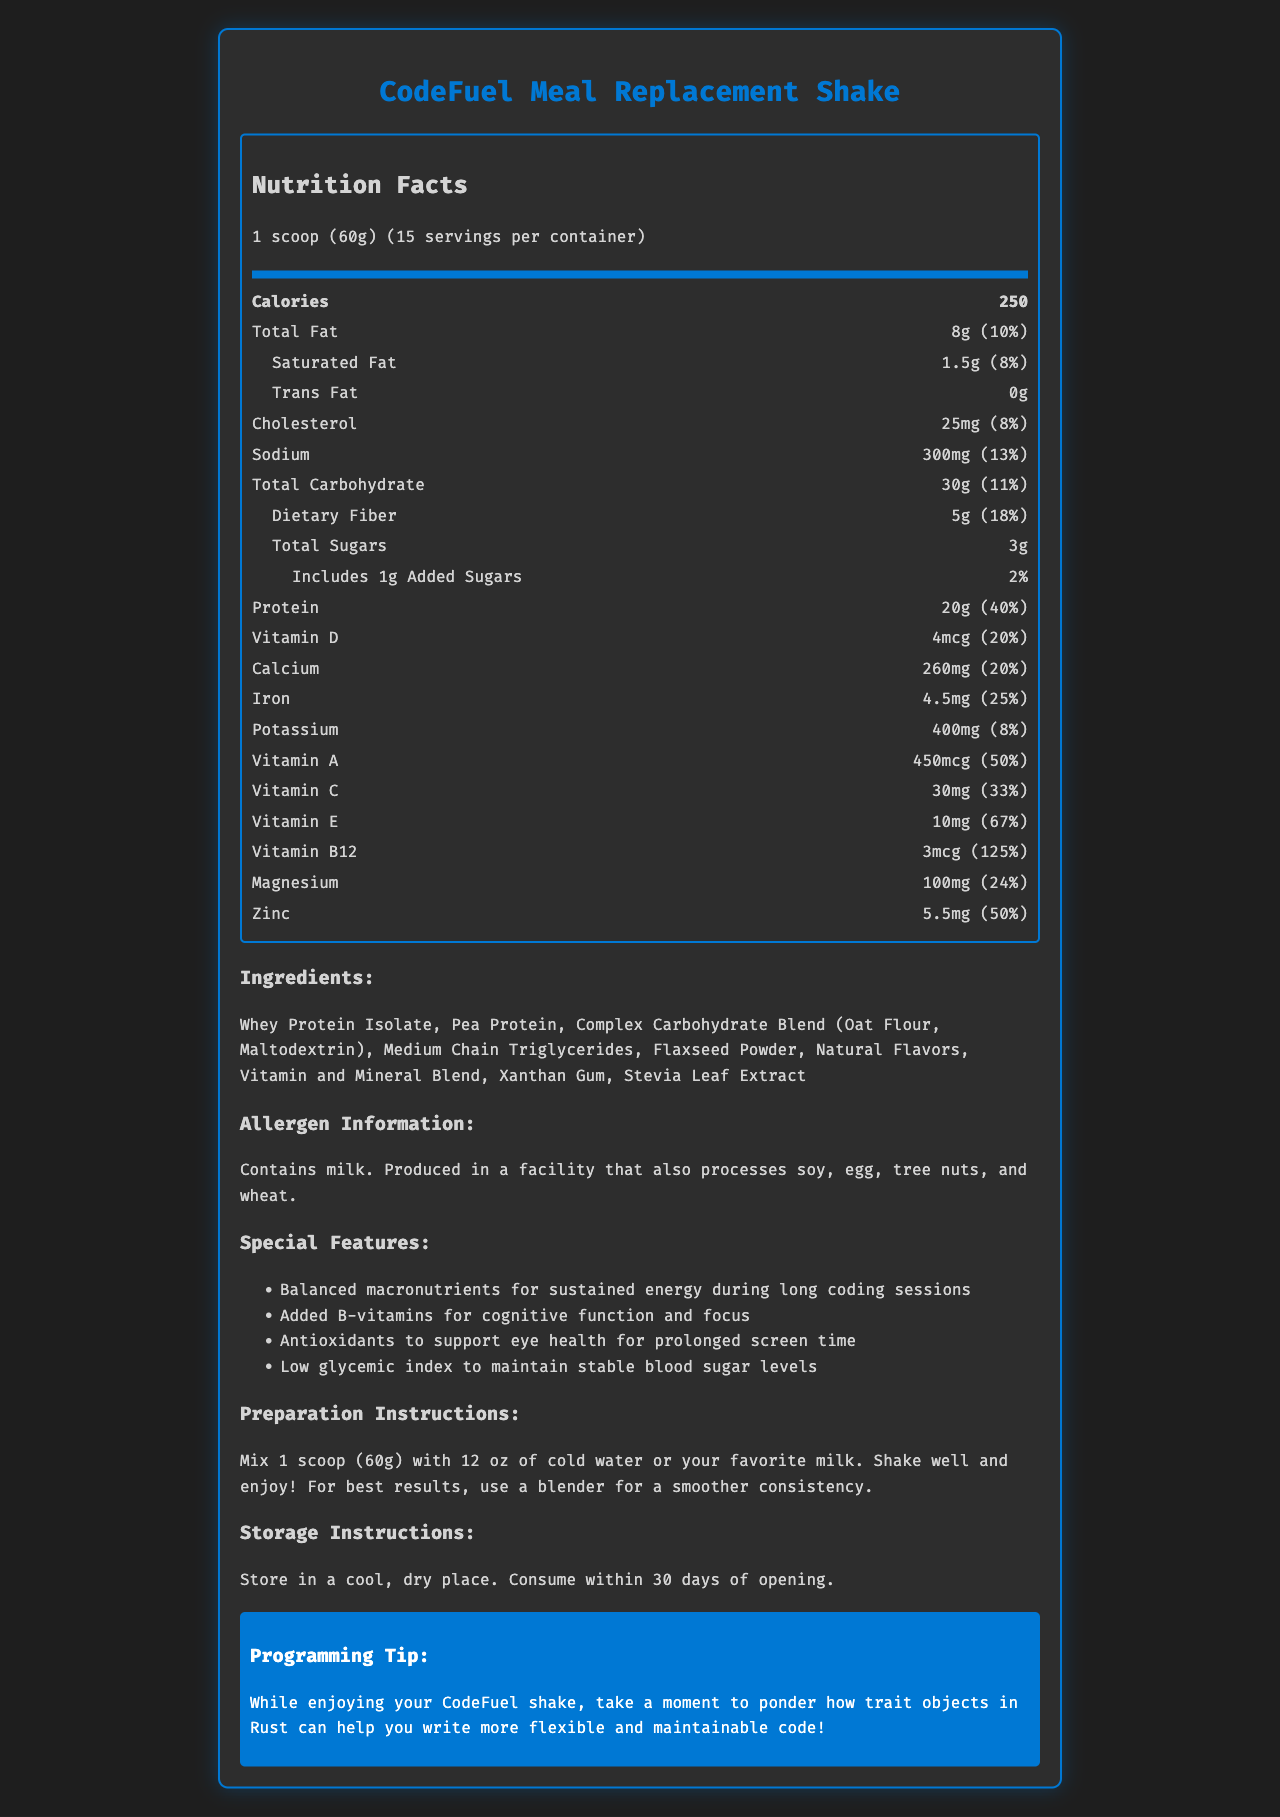What is the serving size of the CodeFuel Meal Replacement Shake? The document specifies that the serving size of the CodeFuel Meal Replacement Shake is 1 scoop, which is equivalent to 60 grams.
Answer: 1 scoop (60g) How many calories are in one serving of the meal replacement shake? The document states that each serving of the CodeFuel Meal Replacement Shake contains 250 calories.
Answer: 250 What is the total fat content in one serving of the meal replacement shake? The document lists the total fat content in one serving as 8 grams, which is also 10% of the daily value.
Answer: 8g Describe the preparation instructions for the CodeFuel Meal Replacement Shake. The preparation instructions state to mix 1 scoop (60g) with 12 ounces of cold water or your favorite milk, shake well, and enjoy. It also suggests using a blender for a smoother consistency.
Answer: Mix 1 scoop (60g) with 12 oz of cold water or your favorite milk. Shake well and enjoy! For best results, use a blender for a smoother consistency. What are the special features designed for long coding sessions? The special features listed include balanced macronutrients for sustained energy, added B-vitamins for cognitive function and focus, antioxidants to support eye health, and a low glycemic index to maintain stable blood sugar levels.
Answer: Balanced macronutrients for sustained energy, Added B-vitamins for cognitive function and focus, Antioxidants for eye health, Low glycemic index for stable blood sugar levels. Does the meal replacement shake contain trans fat? The nutrition facts label shows that the trans fat content in the shake is 0g.
Answer: No Which vitamin has the highest percentage of daily value in the shake? A. Vitamin D B. Vitamin A C. Vitamin B12 D. Vitamin C Vitamin B12 has the highest percentage of daily value, which is 125%.
Answer: C How much protein does one serving contain, and what percentage of the daily value does it represent? One serving of the shake contains 20 grams of protein, which represents 40% of the daily value.
Answer: 20g, 40% What is the allergen information for the product? The allergen information states that the product contains milk and is produced in a facility that also processes soy, egg, tree nuts, and wheat.
Answer: Contains milk. Produced in a facility that also processes soy, egg, tree nuts, and wheat. How should the shake be stored after opening? The storage instructions specify storing the shake in a cool, dry place and consuming it within 30 days of opening.
Answer: Store in a cool, dry place. Consume within 30 days of opening. Which ingredient is NOT included in the meal replacement shake? A. Whey Protein Isolate B. Aspartame C. Xanthan Gum D. Flaxseed Powder The ingredient list does not include aspartame. Instead, it lists whey protein isolate, xanthan gum, and flaxseed powder among others.
Answer: B What is the main focus of the CodeFuel Meal Replacement Shake document? The main idea of the document is to provide detailed information about the nutritional content and benefits of the CodeFuel Meal Replacement Shake, emphasizing its design for sustained energy and cognitive support during long coding sessions.
Answer: The document highlights the nutritional content, special features, ingredients, allergen information, and preparation instructions of the CodeFuel Meal Replacement Shake, designed to provide balanced nutrition and sustained energy for long coding sessions. Can the exact amount of each vitamin and mineral in the Vitamin and Mineral Blend be determined from the document? The document does list certain vitamins and minerals with their amounts and daily values, but it does not specify the exact composition of the entire Vitamin and Mineral Blend.
Answer: Not enough information 